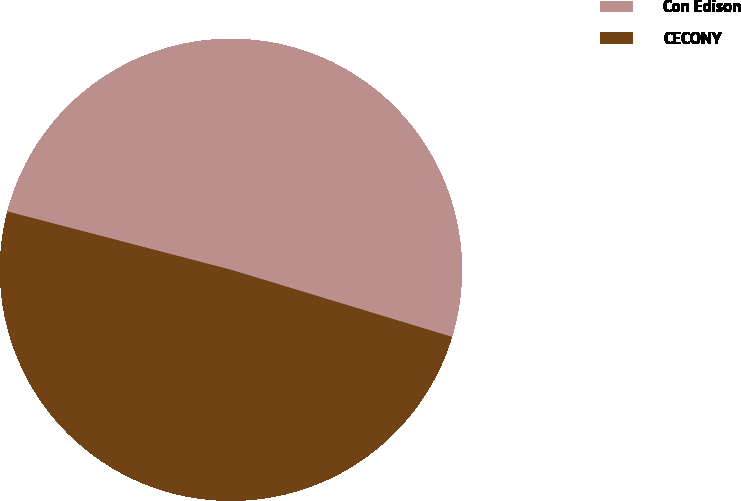Convert chart. <chart><loc_0><loc_0><loc_500><loc_500><pie_chart><fcel>Con Edison<fcel>CECONY<nl><fcel>50.63%<fcel>49.37%<nl></chart> 